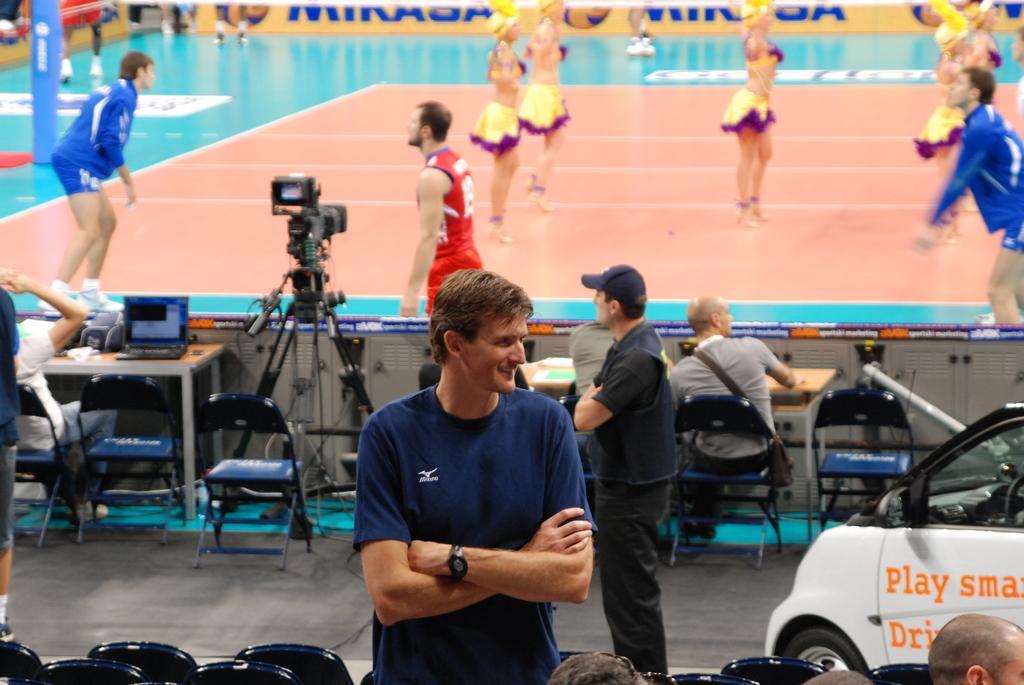In one or two sentences, can you explain what this image depicts? In this image I can see a group of people on the floor, car and two persons are sitting on the chairs and also I can see a camera stand, a table on which a laptop and some objects are there. At the top, I can see a fence. This image is taken may be during a day. 